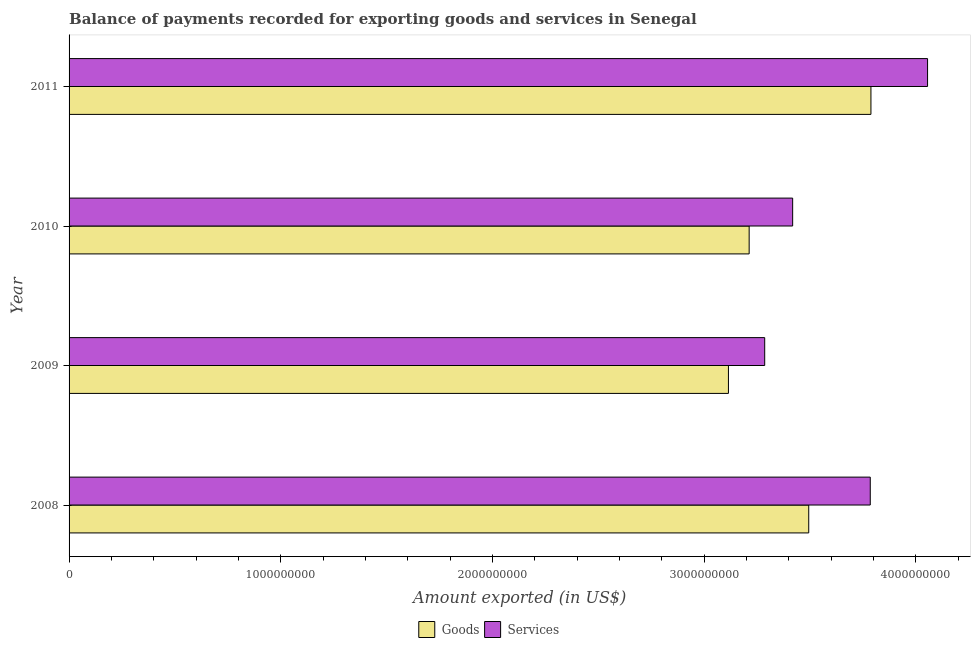How many different coloured bars are there?
Provide a succinct answer. 2. How many groups of bars are there?
Keep it short and to the point. 4. Are the number of bars on each tick of the Y-axis equal?
Your answer should be very brief. Yes. What is the label of the 4th group of bars from the top?
Give a very brief answer. 2008. In how many cases, is the number of bars for a given year not equal to the number of legend labels?
Your response must be concise. 0. What is the amount of goods exported in 2008?
Give a very brief answer. 3.49e+09. Across all years, what is the maximum amount of goods exported?
Your answer should be compact. 3.79e+09. Across all years, what is the minimum amount of services exported?
Ensure brevity in your answer.  3.29e+09. In which year was the amount of goods exported maximum?
Provide a short and direct response. 2011. What is the total amount of services exported in the graph?
Give a very brief answer. 1.45e+1. What is the difference between the amount of goods exported in 2008 and that in 2011?
Offer a very short reply. -2.94e+08. What is the difference between the amount of services exported in 2008 and the amount of goods exported in 2009?
Your answer should be very brief. 6.70e+08. What is the average amount of goods exported per year?
Give a very brief answer. 3.40e+09. In the year 2011, what is the difference between the amount of services exported and amount of goods exported?
Provide a succinct answer. 2.67e+08. What is the ratio of the amount of goods exported in 2008 to that in 2011?
Ensure brevity in your answer.  0.92. What is the difference between the highest and the second highest amount of goods exported?
Give a very brief answer. 2.94e+08. What is the difference between the highest and the lowest amount of services exported?
Provide a short and direct response. 7.69e+08. In how many years, is the amount of services exported greater than the average amount of services exported taken over all years?
Keep it short and to the point. 2. Is the sum of the amount of services exported in 2008 and 2010 greater than the maximum amount of goods exported across all years?
Offer a terse response. Yes. What does the 2nd bar from the top in 2009 represents?
Provide a succinct answer. Goods. What does the 1st bar from the bottom in 2008 represents?
Keep it short and to the point. Goods. Are all the bars in the graph horizontal?
Offer a very short reply. Yes. Does the graph contain grids?
Offer a terse response. No. Where does the legend appear in the graph?
Provide a short and direct response. Bottom center. How many legend labels are there?
Offer a very short reply. 2. What is the title of the graph?
Offer a very short reply. Balance of payments recorded for exporting goods and services in Senegal. Does "Commercial service imports" appear as one of the legend labels in the graph?
Ensure brevity in your answer.  No. What is the label or title of the X-axis?
Offer a very short reply. Amount exported (in US$). What is the label or title of the Y-axis?
Your answer should be compact. Year. What is the Amount exported (in US$) in Goods in 2008?
Your answer should be very brief. 3.49e+09. What is the Amount exported (in US$) of Services in 2008?
Make the answer very short. 3.78e+09. What is the Amount exported (in US$) of Goods in 2009?
Provide a short and direct response. 3.11e+09. What is the Amount exported (in US$) of Services in 2009?
Offer a very short reply. 3.29e+09. What is the Amount exported (in US$) of Goods in 2010?
Your answer should be very brief. 3.21e+09. What is the Amount exported (in US$) in Services in 2010?
Make the answer very short. 3.42e+09. What is the Amount exported (in US$) in Goods in 2011?
Offer a very short reply. 3.79e+09. What is the Amount exported (in US$) of Services in 2011?
Your answer should be very brief. 4.06e+09. Across all years, what is the maximum Amount exported (in US$) in Goods?
Make the answer very short. 3.79e+09. Across all years, what is the maximum Amount exported (in US$) in Services?
Give a very brief answer. 4.06e+09. Across all years, what is the minimum Amount exported (in US$) of Goods?
Provide a short and direct response. 3.11e+09. Across all years, what is the minimum Amount exported (in US$) of Services?
Make the answer very short. 3.29e+09. What is the total Amount exported (in US$) in Goods in the graph?
Your response must be concise. 1.36e+1. What is the total Amount exported (in US$) in Services in the graph?
Give a very brief answer. 1.45e+1. What is the difference between the Amount exported (in US$) of Goods in 2008 and that in 2009?
Your answer should be very brief. 3.79e+08. What is the difference between the Amount exported (in US$) in Services in 2008 and that in 2009?
Provide a short and direct response. 4.99e+08. What is the difference between the Amount exported (in US$) in Goods in 2008 and that in 2010?
Keep it short and to the point. 2.81e+08. What is the difference between the Amount exported (in US$) of Services in 2008 and that in 2010?
Your answer should be very brief. 3.67e+08. What is the difference between the Amount exported (in US$) in Goods in 2008 and that in 2011?
Offer a very short reply. -2.94e+08. What is the difference between the Amount exported (in US$) in Services in 2008 and that in 2011?
Offer a very short reply. -2.71e+08. What is the difference between the Amount exported (in US$) in Goods in 2009 and that in 2010?
Offer a terse response. -9.78e+07. What is the difference between the Amount exported (in US$) of Services in 2009 and that in 2010?
Your response must be concise. -1.32e+08. What is the difference between the Amount exported (in US$) of Goods in 2009 and that in 2011?
Offer a terse response. -6.73e+08. What is the difference between the Amount exported (in US$) of Services in 2009 and that in 2011?
Your answer should be compact. -7.69e+08. What is the difference between the Amount exported (in US$) of Goods in 2010 and that in 2011?
Make the answer very short. -5.75e+08. What is the difference between the Amount exported (in US$) in Services in 2010 and that in 2011?
Offer a terse response. -6.37e+08. What is the difference between the Amount exported (in US$) of Goods in 2008 and the Amount exported (in US$) of Services in 2009?
Provide a succinct answer. 2.08e+08. What is the difference between the Amount exported (in US$) of Goods in 2008 and the Amount exported (in US$) of Services in 2010?
Keep it short and to the point. 7.59e+07. What is the difference between the Amount exported (in US$) in Goods in 2008 and the Amount exported (in US$) in Services in 2011?
Offer a very short reply. -5.61e+08. What is the difference between the Amount exported (in US$) in Goods in 2009 and the Amount exported (in US$) in Services in 2010?
Ensure brevity in your answer.  -3.03e+08. What is the difference between the Amount exported (in US$) in Goods in 2009 and the Amount exported (in US$) in Services in 2011?
Make the answer very short. -9.41e+08. What is the difference between the Amount exported (in US$) in Goods in 2010 and the Amount exported (in US$) in Services in 2011?
Your answer should be compact. -8.43e+08. What is the average Amount exported (in US$) in Goods per year?
Ensure brevity in your answer.  3.40e+09. What is the average Amount exported (in US$) of Services per year?
Provide a short and direct response. 3.64e+09. In the year 2008, what is the difference between the Amount exported (in US$) of Goods and Amount exported (in US$) of Services?
Your answer should be very brief. -2.91e+08. In the year 2009, what is the difference between the Amount exported (in US$) of Goods and Amount exported (in US$) of Services?
Ensure brevity in your answer.  -1.71e+08. In the year 2010, what is the difference between the Amount exported (in US$) in Goods and Amount exported (in US$) in Services?
Provide a succinct answer. -2.06e+08. In the year 2011, what is the difference between the Amount exported (in US$) of Goods and Amount exported (in US$) of Services?
Offer a very short reply. -2.67e+08. What is the ratio of the Amount exported (in US$) of Goods in 2008 to that in 2009?
Make the answer very short. 1.12. What is the ratio of the Amount exported (in US$) of Services in 2008 to that in 2009?
Give a very brief answer. 1.15. What is the ratio of the Amount exported (in US$) in Goods in 2008 to that in 2010?
Keep it short and to the point. 1.09. What is the ratio of the Amount exported (in US$) of Services in 2008 to that in 2010?
Offer a very short reply. 1.11. What is the ratio of the Amount exported (in US$) in Goods in 2008 to that in 2011?
Your answer should be very brief. 0.92. What is the ratio of the Amount exported (in US$) of Services in 2008 to that in 2011?
Your answer should be compact. 0.93. What is the ratio of the Amount exported (in US$) in Goods in 2009 to that in 2010?
Provide a succinct answer. 0.97. What is the ratio of the Amount exported (in US$) in Services in 2009 to that in 2010?
Your response must be concise. 0.96. What is the ratio of the Amount exported (in US$) in Goods in 2009 to that in 2011?
Ensure brevity in your answer.  0.82. What is the ratio of the Amount exported (in US$) of Services in 2009 to that in 2011?
Give a very brief answer. 0.81. What is the ratio of the Amount exported (in US$) of Goods in 2010 to that in 2011?
Offer a terse response. 0.85. What is the ratio of the Amount exported (in US$) in Services in 2010 to that in 2011?
Your answer should be very brief. 0.84. What is the difference between the highest and the second highest Amount exported (in US$) in Goods?
Offer a very short reply. 2.94e+08. What is the difference between the highest and the second highest Amount exported (in US$) of Services?
Your answer should be very brief. 2.71e+08. What is the difference between the highest and the lowest Amount exported (in US$) of Goods?
Offer a very short reply. 6.73e+08. What is the difference between the highest and the lowest Amount exported (in US$) of Services?
Keep it short and to the point. 7.69e+08. 